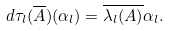<formula> <loc_0><loc_0><loc_500><loc_500>d \tau _ { l } ( \overline { A } ) ( \alpha _ { l } ) = \overline { \lambda _ { l } ( A ) } \alpha _ { l } .</formula> 